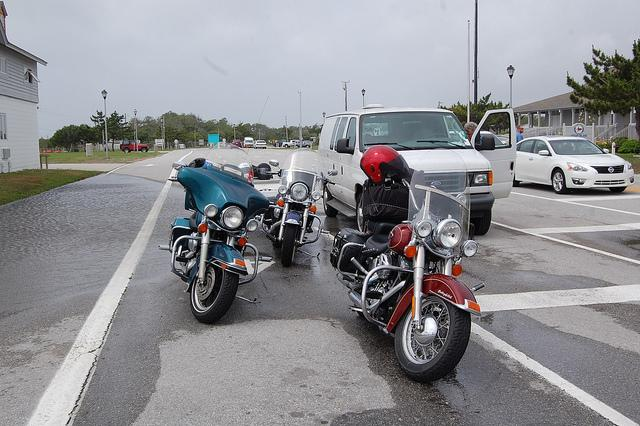Where are these vehicles located? Please explain your reasoning. parking lot. They are in between lines in a parking lot. 